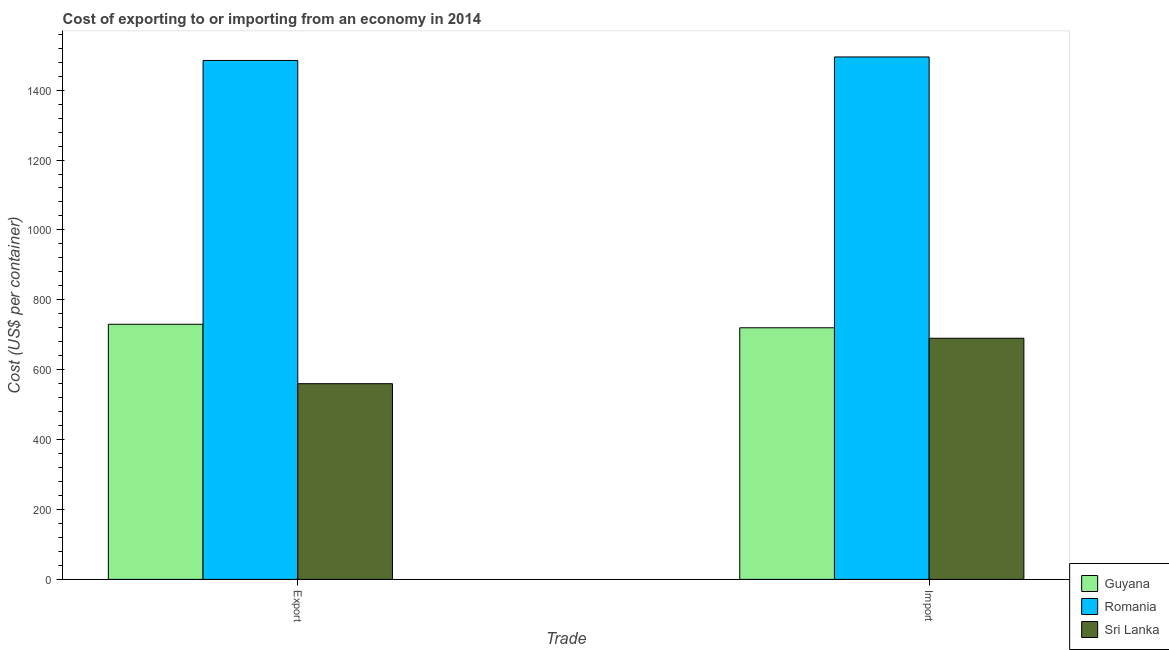Are the number of bars per tick equal to the number of legend labels?
Offer a terse response. Yes. Are the number of bars on each tick of the X-axis equal?
Offer a very short reply. Yes. How many bars are there on the 2nd tick from the right?
Provide a short and direct response. 3. What is the label of the 1st group of bars from the left?
Your answer should be compact. Export. What is the import cost in Sri Lanka?
Offer a very short reply. 690. Across all countries, what is the maximum import cost?
Your response must be concise. 1495. Across all countries, what is the minimum import cost?
Make the answer very short. 690. In which country was the import cost maximum?
Your response must be concise. Romania. In which country was the export cost minimum?
Provide a succinct answer. Sri Lanka. What is the total export cost in the graph?
Ensure brevity in your answer.  2775. What is the difference between the import cost in Sri Lanka and that in Guyana?
Give a very brief answer. -30. What is the difference between the import cost in Sri Lanka and the export cost in Guyana?
Offer a very short reply. -40. What is the average export cost per country?
Your response must be concise. 925. What is the difference between the export cost and import cost in Sri Lanka?
Ensure brevity in your answer.  -130. What is the ratio of the export cost in Sri Lanka to that in Guyana?
Offer a very short reply. 0.77. Is the export cost in Sri Lanka less than that in Guyana?
Offer a very short reply. Yes. What does the 1st bar from the left in Import represents?
Offer a terse response. Guyana. What does the 3rd bar from the right in Import represents?
Provide a short and direct response. Guyana. How many countries are there in the graph?
Offer a terse response. 3. Does the graph contain any zero values?
Make the answer very short. No. Where does the legend appear in the graph?
Keep it short and to the point. Bottom right. How many legend labels are there?
Provide a succinct answer. 3. What is the title of the graph?
Provide a short and direct response. Cost of exporting to or importing from an economy in 2014. What is the label or title of the X-axis?
Offer a very short reply. Trade. What is the label or title of the Y-axis?
Offer a terse response. Cost (US$ per container). What is the Cost (US$ per container) of Guyana in Export?
Provide a short and direct response. 730. What is the Cost (US$ per container) of Romania in Export?
Offer a very short reply. 1485. What is the Cost (US$ per container) in Sri Lanka in Export?
Ensure brevity in your answer.  560. What is the Cost (US$ per container) of Guyana in Import?
Provide a succinct answer. 720. What is the Cost (US$ per container) in Romania in Import?
Provide a succinct answer. 1495. What is the Cost (US$ per container) in Sri Lanka in Import?
Your response must be concise. 690. Across all Trade, what is the maximum Cost (US$ per container) in Guyana?
Provide a succinct answer. 730. Across all Trade, what is the maximum Cost (US$ per container) of Romania?
Your answer should be very brief. 1495. Across all Trade, what is the maximum Cost (US$ per container) in Sri Lanka?
Provide a succinct answer. 690. Across all Trade, what is the minimum Cost (US$ per container) of Guyana?
Your response must be concise. 720. Across all Trade, what is the minimum Cost (US$ per container) in Romania?
Give a very brief answer. 1485. Across all Trade, what is the minimum Cost (US$ per container) in Sri Lanka?
Your answer should be very brief. 560. What is the total Cost (US$ per container) in Guyana in the graph?
Keep it short and to the point. 1450. What is the total Cost (US$ per container) in Romania in the graph?
Provide a succinct answer. 2980. What is the total Cost (US$ per container) in Sri Lanka in the graph?
Ensure brevity in your answer.  1250. What is the difference between the Cost (US$ per container) of Sri Lanka in Export and that in Import?
Offer a very short reply. -130. What is the difference between the Cost (US$ per container) of Guyana in Export and the Cost (US$ per container) of Romania in Import?
Ensure brevity in your answer.  -765. What is the difference between the Cost (US$ per container) of Romania in Export and the Cost (US$ per container) of Sri Lanka in Import?
Provide a short and direct response. 795. What is the average Cost (US$ per container) of Guyana per Trade?
Make the answer very short. 725. What is the average Cost (US$ per container) of Romania per Trade?
Keep it short and to the point. 1490. What is the average Cost (US$ per container) of Sri Lanka per Trade?
Your answer should be very brief. 625. What is the difference between the Cost (US$ per container) in Guyana and Cost (US$ per container) in Romania in Export?
Your answer should be compact. -755. What is the difference between the Cost (US$ per container) of Guyana and Cost (US$ per container) of Sri Lanka in Export?
Provide a short and direct response. 170. What is the difference between the Cost (US$ per container) of Romania and Cost (US$ per container) of Sri Lanka in Export?
Keep it short and to the point. 925. What is the difference between the Cost (US$ per container) in Guyana and Cost (US$ per container) in Romania in Import?
Ensure brevity in your answer.  -775. What is the difference between the Cost (US$ per container) of Guyana and Cost (US$ per container) of Sri Lanka in Import?
Make the answer very short. 30. What is the difference between the Cost (US$ per container) in Romania and Cost (US$ per container) in Sri Lanka in Import?
Provide a short and direct response. 805. What is the ratio of the Cost (US$ per container) of Guyana in Export to that in Import?
Ensure brevity in your answer.  1.01. What is the ratio of the Cost (US$ per container) of Sri Lanka in Export to that in Import?
Offer a very short reply. 0.81. What is the difference between the highest and the second highest Cost (US$ per container) of Romania?
Ensure brevity in your answer.  10. What is the difference between the highest and the second highest Cost (US$ per container) in Sri Lanka?
Make the answer very short. 130. What is the difference between the highest and the lowest Cost (US$ per container) in Sri Lanka?
Keep it short and to the point. 130. 